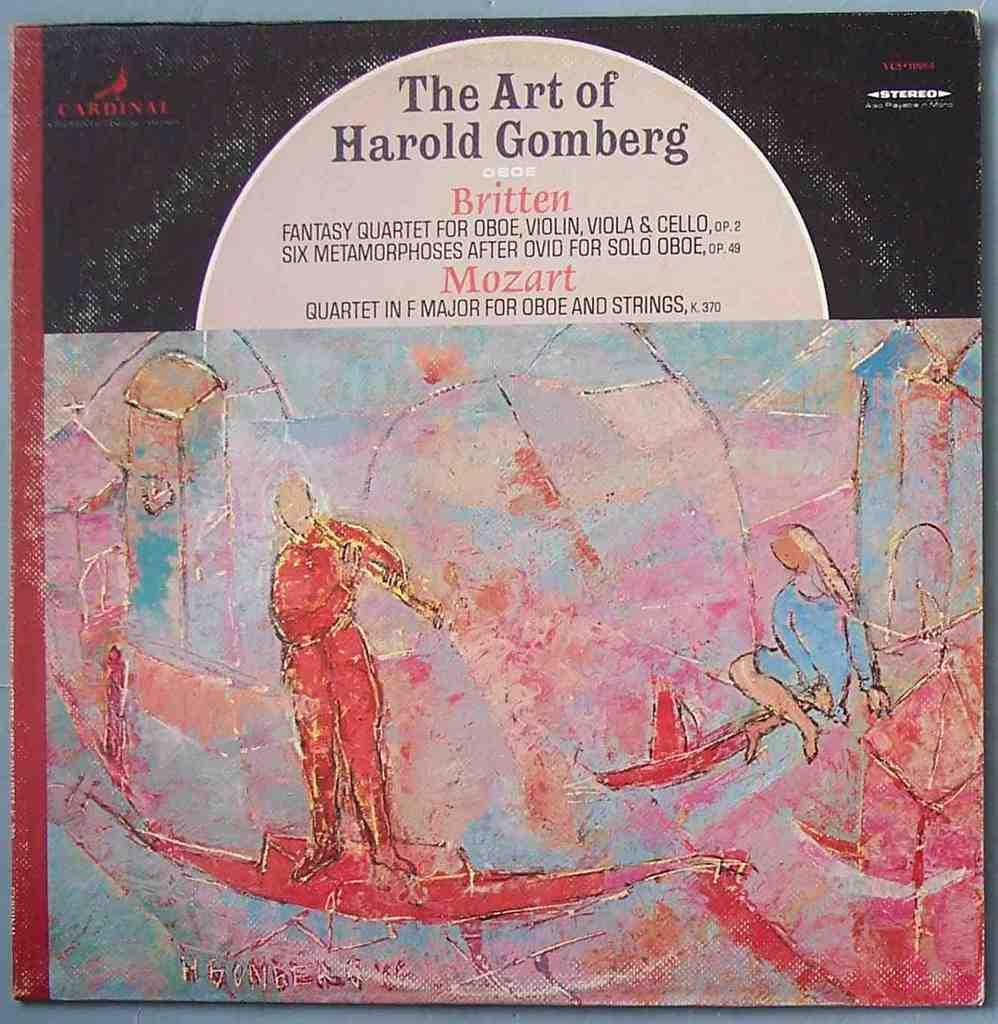What object is present in the image that is related to reading or learning? There is a book in the image. What can be seen on the cover of the book? The book has a painting of people. What else can be found inside the book besides the painting? The book has text. What type of string is being used to hold the worm in the image? There is no string or worm present in the image. 